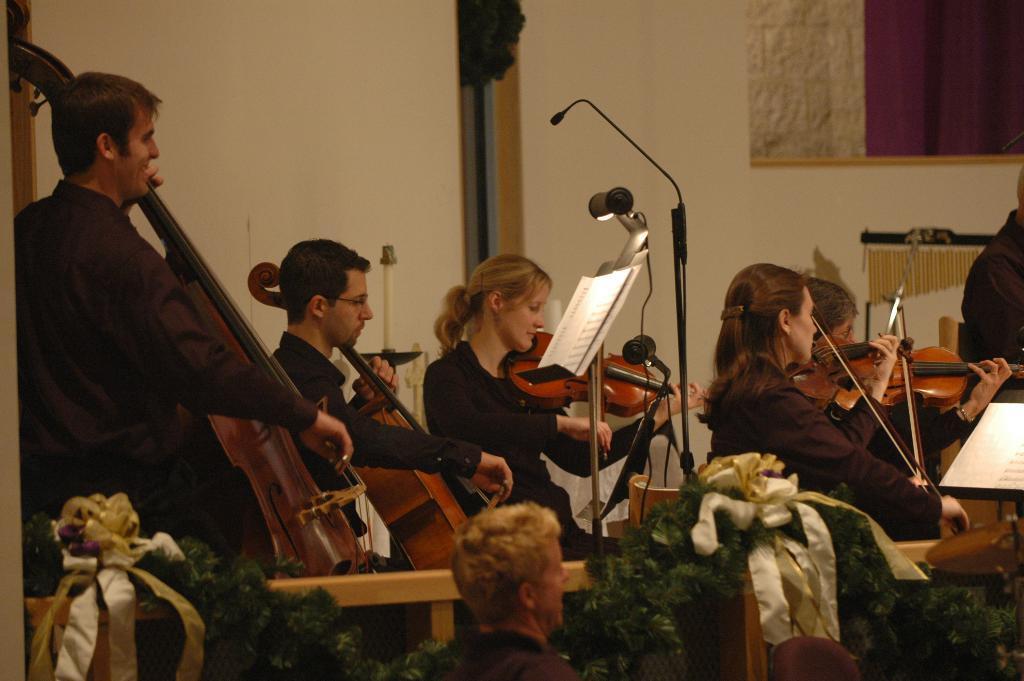How would you summarize this image in a sentence or two? As we can see in the image there is a wall, few people sitting over here and holding guitars in their hands and there is a mic and paper. 